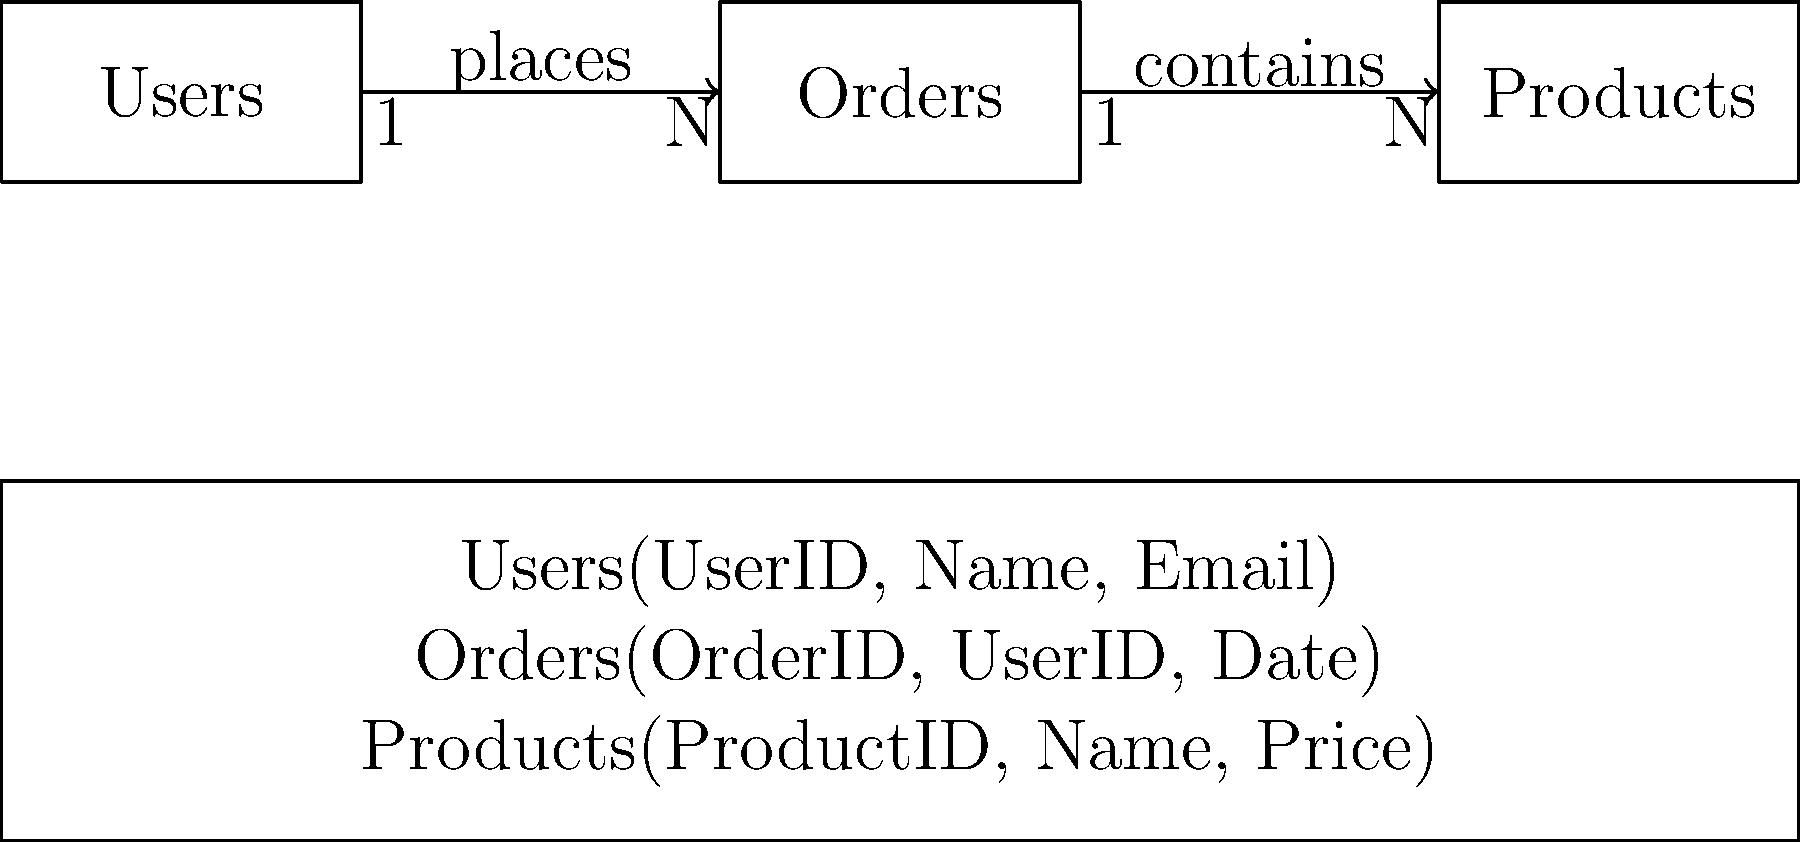Which of the following database schema representations correctly matches the entity-relationship diagram shown above?

A) Users(UserID, Name, Email)
   Orders(OrderID, UserID, Date, ProductID)
   Products(ProductID, Name, Price)

B) Users(UserID, Name, Email)
   Orders(OrderID, UserID, Date)
   Products(ProductID, Name, Price)
   OrderProducts(OrderID, ProductID)

C) Users(UserID, Name, Email)
   Orders(OrderID, UserID, Date)
   Products(ProductID, Name, Price)

D) Users(UserID, Name, Email, OrderID)
   Orders(OrderID, Date, ProductID)
   Products(ProductID, Name, Price) To determine the correct database schema representation, let's analyze the entity-relationship diagram and match it to the given options:

1. The diagram shows three entities: Users, Orders, and Products.

2. There's a one-to-many relationship between Users and Orders (1:N), indicating that one user can place multiple orders.

3. There's also a one-to-many relationship between Orders and Products (1:N), suggesting that one order can contain multiple products.

4. In the schema representation, we need to reflect these relationships correctly:
   - Users table should have UserID as the primary key.
   - Orders table should have OrderID as the primary key and UserID as a foreign key to establish the relationship with Users.
   - Products table should have ProductID as the primary key.

5. The relationship between Orders and Products is many-to-many (N:N), which typically requires a junction table in a relational database. However, this junction table is not explicitly shown in the given options.

6. Examining the options:
   A) Incorrect: It includes ProductID in the Orders table, which doesn't accurately represent the many-to-many relationship.
   B) Correct: It includes a separate OrderProducts table to represent the many-to-many relationship between Orders and Products.
   C) Matches the diagram but doesn't explicitly show how the Orders-Products relationship is implemented.
   D) Incorrect: It incorrectly places OrderID in the Users table and ProductID in the Orders table.

7. Option C is the closest match to the diagram and schema representation shown, although it doesn't explicitly show how the Orders-Products relationship is implemented.
Answer: C 